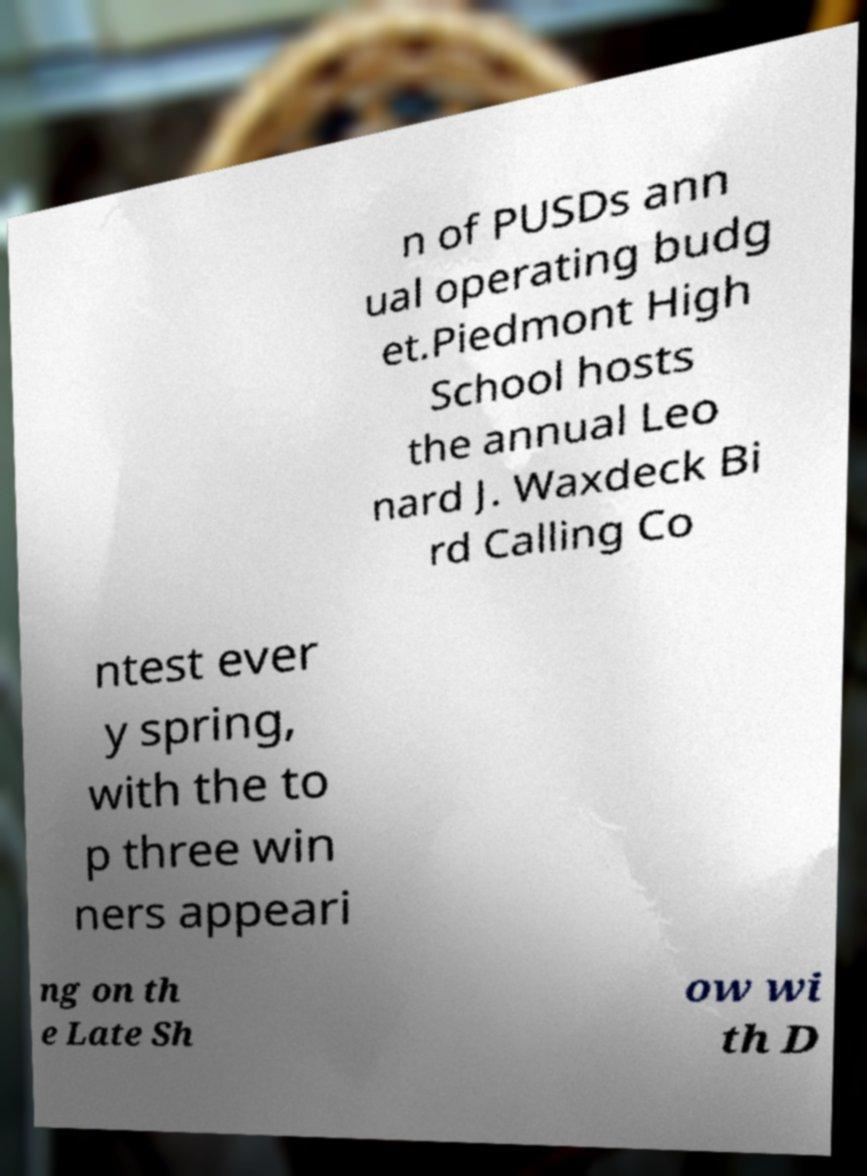For documentation purposes, I need the text within this image transcribed. Could you provide that? n of PUSDs ann ual operating budg et.Piedmont High School hosts the annual Leo nard J. Waxdeck Bi rd Calling Co ntest ever y spring, with the to p three win ners appeari ng on th e Late Sh ow wi th D 